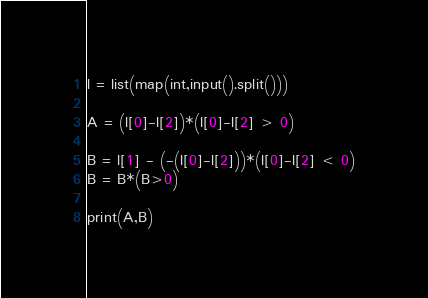<code> <loc_0><loc_0><loc_500><loc_500><_Python_>l = list(map(int,input().split()))

A = (l[0]-l[2])*(l[0]-l[2] > 0)

B = l[1] - (-(l[0]-l[2]))*(l[0]-l[2] < 0)
B = B*(B>0)

print(A,B)</code> 